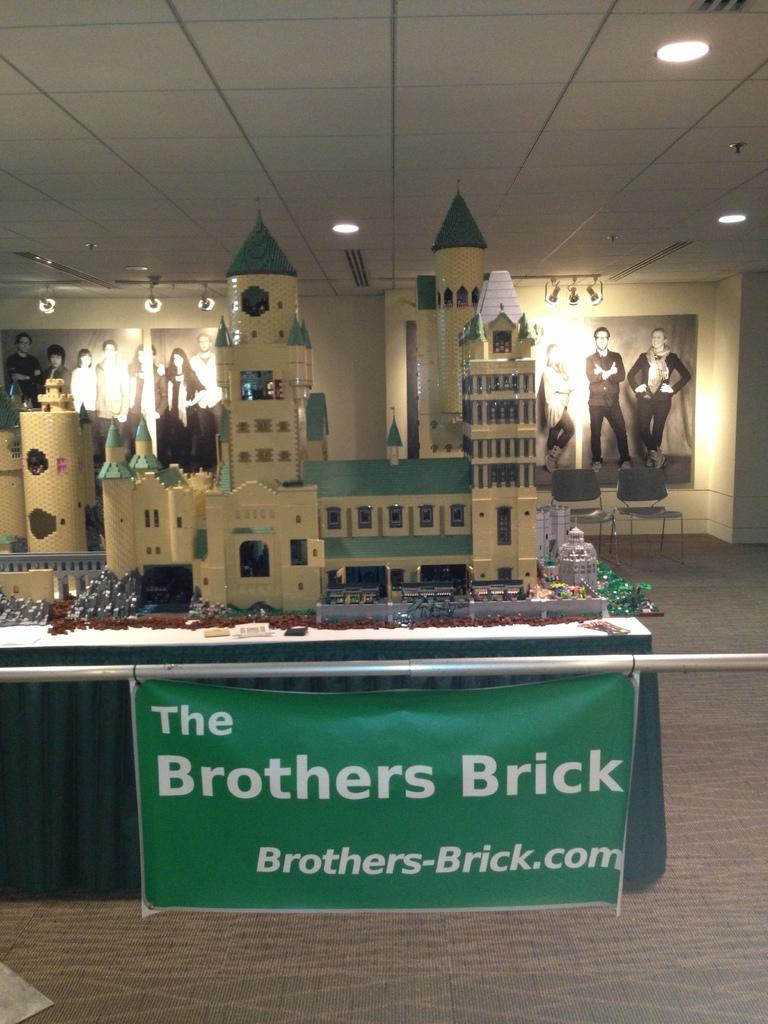<image>
Render a clear and concise summary of the photo. Castle project with a green banner that has The Brothers Brick and Brothers-Brick.com in white lettering. 